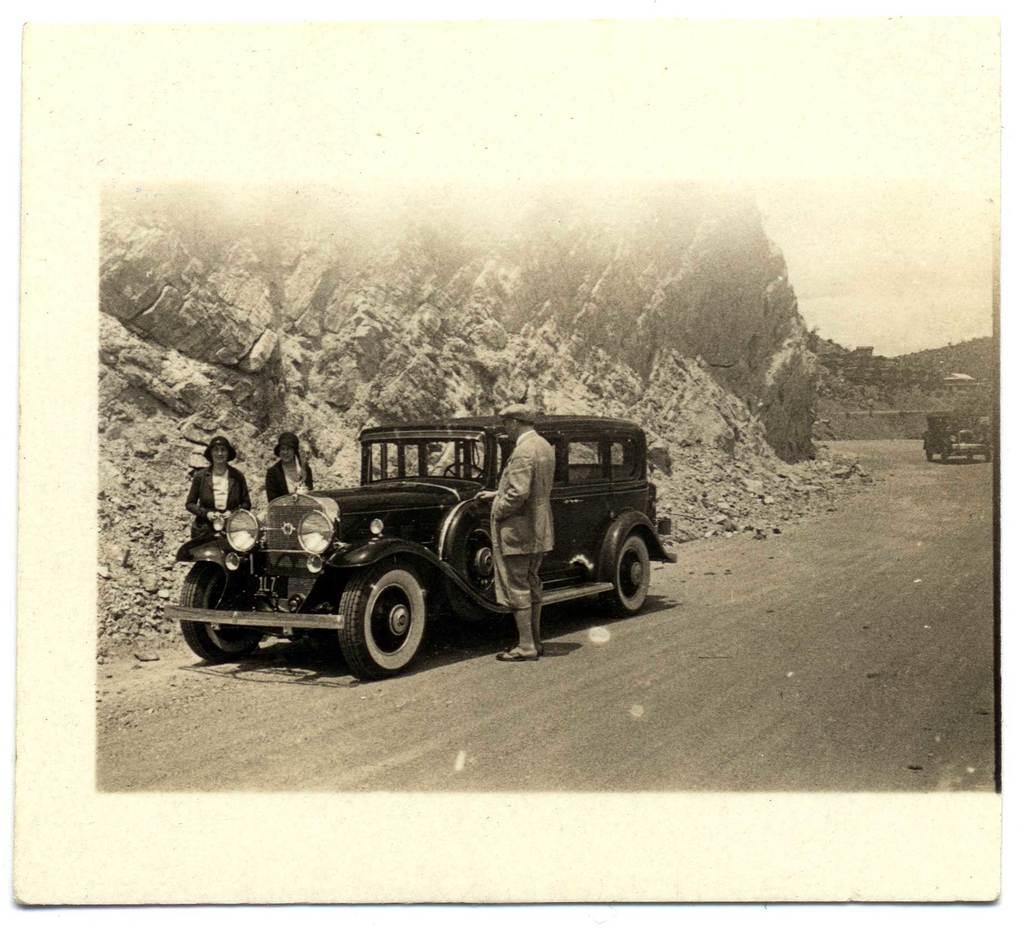Please provide a concise description of this image. Black and white picture. Vehicles are on the road. Beside this vehicle three people standing. This is rock wall.  